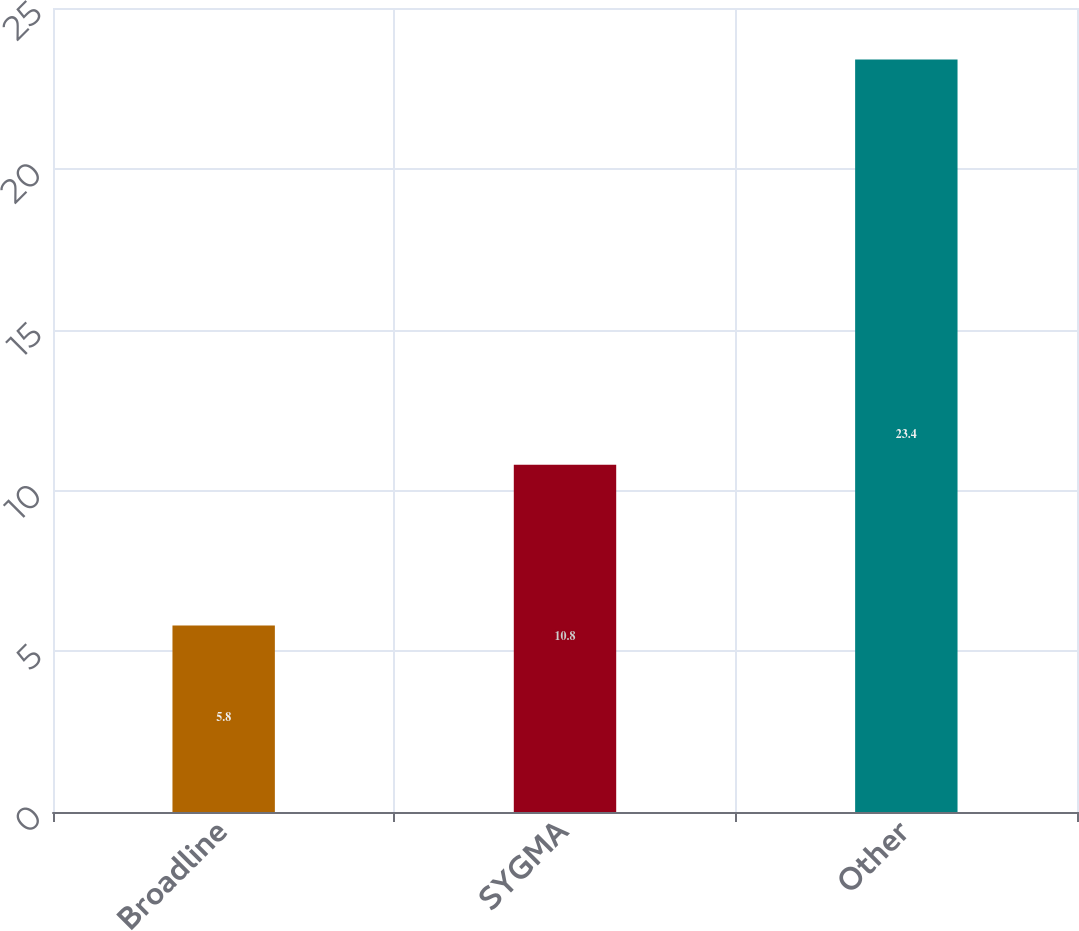<chart> <loc_0><loc_0><loc_500><loc_500><bar_chart><fcel>Broadline<fcel>SYGMA<fcel>Other<nl><fcel>5.8<fcel>10.8<fcel>23.4<nl></chart> 